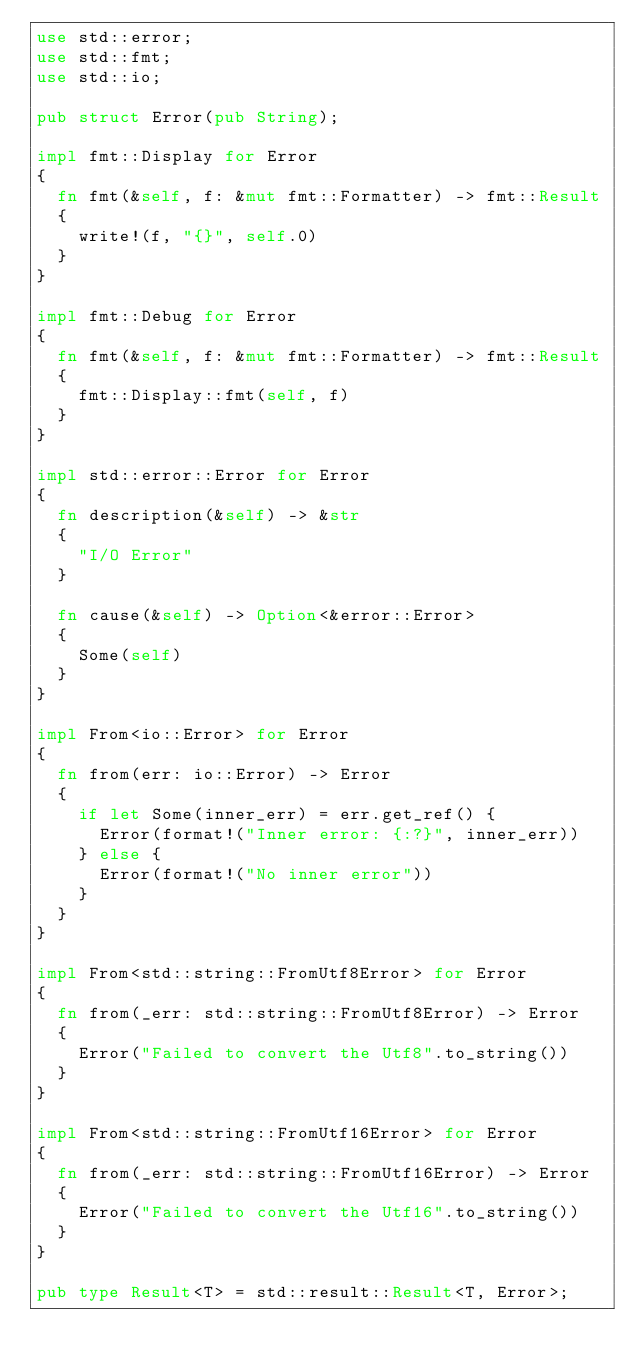Convert code to text. <code><loc_0><loc_0><loc_500><loc_500><_Rust_>use std::error;
use std::fmt;
use std::io;

pub struct Error(pub String);

impl fmt::Display for Error
{
	fn fmt(&self, f: &mut fmt::Formatter) -> fmt::Result
	{
		write!(f, "{}", self.0)
	}
}

impl fmt::Debug for Error
{
	fn fmt(&self, f: &mut fmt::Formatter) -> fmt::Result 
	{
		fmt::Display::fmt(self, f)
	}
}

impl std::error::Error for Error
{
	fn description(&self) -> &str
	{
		"I/O Error"
	}

	fn cause(&self) -> Option<&error::Error>
	{
		Some(self)
	}
}

impl From<io::Error> for Error
{
	fn from(err: io::Error) -> Error
	{
		if let Some(inner_err) = err.get_ref() {
			Error(format!("Inner error: {:?}", inner_err))
		} else {
			Error(format!("No inner error"))
		}
	}
}

impl From<std::string::FromUtf8Error> for Error
{
	fn from(_err: std::string::FromUtf8Error) -> Error
	{
		Error("Failed to convert the Utf8".to_string())
	}
}

impl From<std::string::FromUtf16Error> for Error
{
	fn from(_err: std::string::FromUtf16Error) -> Error
	{
		Error("Failed to convert the Utf16".to_string())
	}
}

pub type Result<T> = std::result::Result<T, Error>;</code> 